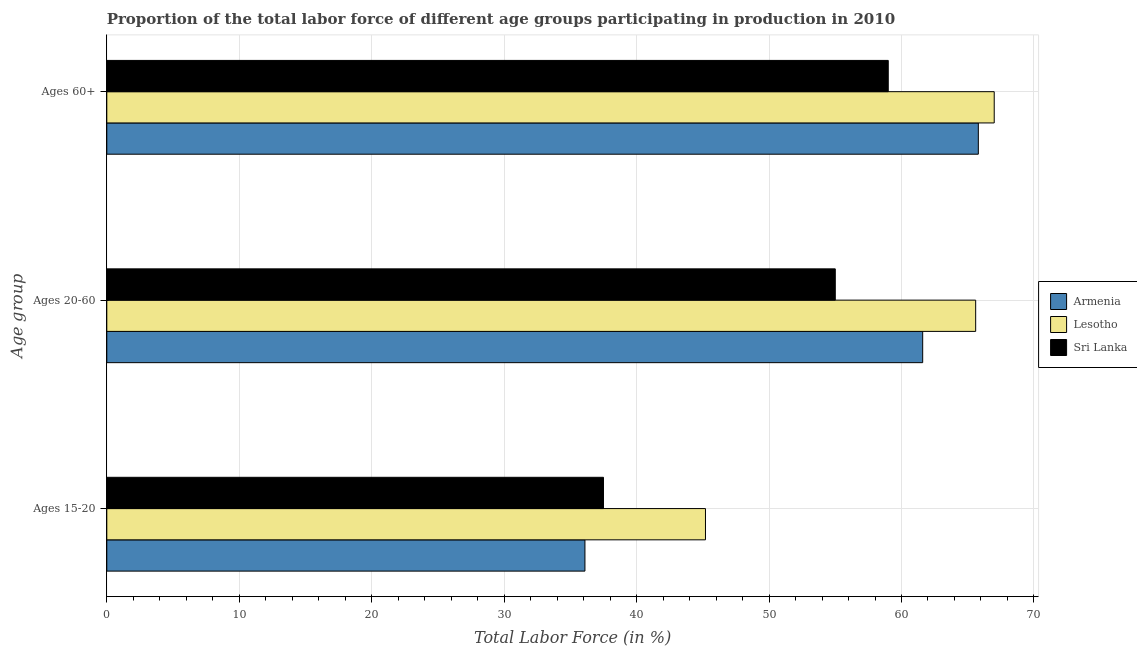How many groups of bars are there?
Keep it short and to the point. 3. How many bars are there on the 2nd tick from the bottom?
Ensure brevity in your answer.  3. What is the label of the 2nd group of bars from the top?
Offer a very short reply. Ages 20-60. What is the percentage of labor force within the age group 15-20 in Lesotho?
Provide a short and direct response. 45.2. Across all countries, what is the maximum percentage of labor force within the age group 20-60?
Make the answer very short. 65.6. Across all countries, what is the minimum percentage of labor force within the age group 15-20?
Your answer should be very brief. 36.1. In which country was the percentage of labor force within the age group 15-20 maximum?
Your answer should be very brief. Lesotho. In which country was the percentage of labor force within the age group 20-60 minimum?
Provide a succinct answer. Sri Lanka. What is the total percentage of labor force within the age group 20-60 in the graph?
Keep it short and to the point. 182.2. What is the difference between the percentage of labor force within the age group 20-60 in Lesotho and the percentage of labor force within the age group 15-20 in Sri Lanka?
Your response must be concise. 28.1. What is the average percentage of labor force within the age group 15-20 per country?
Make the answer very short. 39.6. What is the difference between the percentage of labor force within the age group 20-60 and percentage of labor force within the age group 15-20 in Armenia?
Your answer should be compact. 25.5. In how many countries, is the percentage of labor force within the age group 20-60 greater than 6 %?
Provide a short and direct response. 3. What is the ratio of the percentage of labor force within the age group 15-20 in Lesotho to that in Armenia?
Offer a very short reply. 1.25. Is the percentage of labor force within the age group 15-20 in Lesotho less than that in Armenia?
Your answer should be very brief. No. Is the difference between the percentage of labor force within the age group 15-20 in Armenia and Lesotho greater than the difference between the percentage of labor force within the age group 20-60 in Armenia and Lesotho?
Ensure brevity in your answer.  No. What is the difference between the highest and the second highest percentage of labor force above age 60?
Make the answer very short. 1.2. What is the difference between the highest and the lowest percentage of labor force above age 60?
Provide a short and direct response. 8. In how many countries, is the percentage of labor force above age 60 greater than the average percentage of labor force above age 60 taken over all countries?
Your answer should be very brief. 2. Is the sum of the percentage of labor force within the age group 20-60 in Armenia and Lesotho greater than the maximum percentage of labor force above age 60 across all countries?
Give a very brief answer. Yes. What does the 3rd bar from the top in Ages 60+ represents?
Your answer should be very brief. Armenia. What does the 3rd bar from the bottom in Ages 20-60 represents?
Offer a terse response. Sri Lanka. Is it the case that in every country, the sum of the percentage of labor force within the age group 15-20 and percentage of labor force within the age group 20-60 is greater than the percentage of labor force above age 60?
Provide a short and direct response. Yes. How many bars are there?
Make the answer very short. 9. What is the difference between two consecutive major ticks on the X-axis?
Keep it short and to the point. 10. Are the values on the major ticks of X-axis written in scientific E-notation?
Give a very brief answer. No. How many legend labels are there?
Your answer should be compact. 3. What is the title of the graph?
Make the answer very short. Proportion of the total labor force of different age groups participating in production in 2010. Does "South Asia" appear as one of the legend labels in the graph?
Your answer should be very brief. No. What is the label or title of the Y-axis?
Provide a succinct answer. Age group. What is the Total Labor Force (in %) in Armenia in Ages 15-20?
Your response must be concise. 36.1. What is the Total Labor Force (in %) in Lesotho in Ages 15-20?
Your response must be concise. 45.2. What is the Total Labor Force (in %) of Sri Lanka in Ages 15-20?
Your response must be concise. 37.5. What is the Total Labor Force (in %) in Armenia in Ages 20-60?
Make the answer very short. 61.6. What is the Total Labor Force (in %) in Lesotho in Ages 20-60?
Provide a short and direct response. 65.6. What is the Total Labor Force (in %) in Sri Lanka in Ages 20-60?
Give a very brief answer. 55. What is the Total Labor Force (in %) of Armenia in Ages 60+?
Offer a very short reply. 65.8. What is the Total Labor Force (in %) in Sri Lanka in Ages 60+?
Your answer should be compact. 59. Across all Age group, what is the maximum Total Labor Force (in %) in Armenia?
Make the answer very short. 65.8. Across all Age group, what is the maximum Total Labor Force (in %) in Lesotho?
Keep it short and to the point. 67. Across all Age group, what is the minimum Total Labor Force (in %) of Armenia?
Offer a very short reply. 36.1. Across all Age group, what is the minimum Total Labor Force (in %) of Lesotho?
Keep it short and to the point. 45.2. Across all Age group, what is the minimum Total Labor Force (in %) of Sri Lanka?
Your answer should be very brief. 37.5. What is the total Total Labor Force (in %) in Armenia in the graph?
Provide a short and direct response. 163.5. What is the total Total Labor Force (in %) in Lesotho in the graph?
Provide a short and direct response. 177.8. What is the total Total Labor Force (in %) in Sri Lanka in the graph?
Offer a terse response. 151.5. What is the difference between the Total Labor Force (in %) of Armenia in Ages 15-20 and that in Ages 20-60?
Your answer should be very brief. -25.5. What is the difference between the Total Labor Force (in %) in Lesotho in Ages 15-20 and that in Ages 20-60?
Offer a very short reply. -20.4. What is the difference between the Total Labor Force (in %) of Sri Lanka in Ages 15-20 and that in Ages 20-60?
Provide a short and direct response. -17.5. What is the difference between the Total Labor Force (in %) in Armenia in Ages 15-20 and that in Ages 60+?
Your answer should be compact. -29.7. What is the difference between the Total Labor Force (in %) in Lesotho in Ages 15-20 and that in Ages 60+?
Your answer should be very brief. -21.8. What is the difference between the Total Labor Force (in %) in Sri Lanka in Ages 15-20 and that in Ages 60+?
Offer a very short reply. -21.5. What is the difference between the Total Labor Force (in %) of Sri Lanka in Ages 20-60 and that in Ages 60+?
Your answer should be compact. -4. What is the difference between the Total Labor Force (in %) of Armenia in Ages 15-20 and the Total Labor Force (in %) of Lesotho in Ages 20-60?
Ensure brevity in your answer.  -29.5. What is the difference between the Total Labor Force (in %) in Armenia in Ages 15-20 and the Total Labor Force (in %) in Sri Lanka in Ages 20-60?
Give a very brief answer. -18.9. What is the difference between the Total Labor Force (in %) of Armenia in Ages 15-20 and the Total Labor Force (in %) of Lesotho in Ages 60+?
Offer a terse response. -30.9. What is the difference between the Total Labor Force (in %) of Armenia in Ages 15-20 and the Total Labor Force (in %) of Sri Lanka in Ages 60+?
Provide a short and direct response. -22.9. What is the difference between the Total Labor Force (in %) of Lesotho in Ages 15-20 and the Total Labor Force (in %) of Sri Lanka in Ages 60+?
Ensure brevity in your answer.  -13.8. What is the difference between the Total Labor Force (in %) in Armenia in Ages 20-60 and the Total Labor Force (in %) in Lesotho in Ages 60+?
Keep it short and to the point. -5.4. What is the difference between the Total Labor Force (in %) of Armenia in Ages 20-60 and the Total Labor Force (in %) of Sri Lanka in Ages 60+?
Give a very brief answer. 2.6. What is the difference between the Total Labor Force (in %) in Lesotho in Ages 20-60 and the Total Labor Force (in %) in Sri Lanka in Ages 60+?
Make the answer very short. 6.6. What is the average Total Labor Force (in %) in Armenia per Age group?
Offer a very short reply. 54.5. What is the average Total Labor Force (in %) in Lesotho per Age group?
Your answer should be very brief. 59.27. What is the average Total Labor Force (in %) of Sri Lanka per Age group?
Give a very brief answer. 50.5. What is the difference between the Total Labor Force (in %) of Armenia and Total Labor Force (in %) of Lesotho in Ages 15-20?
Provide a short and direct response. -9.1. What is the difference between the Total Labor Force (in %) of Armenia and Total Labor Force (in %) of Sri Lanka in Ages 15-20?
Make the answer very short. -1.4. What is the difference between the Total Labor Force (in %) of Lesotho and Total Labor Force (in %) of Sri Lanka in Ages 15-20?
Give a very brief answer. 7.7. What is the difference between the Total Labor Force (in %) of Armenia and Total Labor Force (in %) of Sri Lanka in Ages 20-60?
Your answer should be very brief. 6.6. What is the difference between the Total Labor Force (in %) of Lesotho and Total Labor Force (in %) of Sri Lanka in Ages 20-60?
Give a very brief answer. 10.6. What is the difference between the Total Labor Force (in %) of Armenia and Total Labor Force (in %) of Lesotho in Ages 60+?
Make the answer very short. -1.2. What is the ratio of the Total Labor Force (in %) in Armenia in Ages 15-20 to that in Ages 20-60?
Your answer should be very brief. 0.59. What is the ratio of the Total Labor Force (in %) in Lesotho in Ages 15-20 to that in Ages 20-60?
Provide a succinct answer. 0.69. What is the ratio of the Total Labor Force (in %) in Sri Lanka in Ages 15-20 to that in Ages 20-60?
Keep it short and to the point. 0.68. What is the ratio of the Total Labor Force (in %) of Armenia in Ages 15-20 to that in Ages 60+?
Give a very brief answer. 0.55. What is the ratio of the Total Labor Force (in %) in Lesotho in Ages 15-20 to that in Ages 60+?
Your response must be concise. 0.67. What is the ratio of the Total Labor Force (in %) in Sri Lanka in Ages 15-20 to that in Ages 60+?
Your answer should be compact. 0.64. What is the ratio of the Total Labor Force (in %) in Armenia in Ages 20-60 to that in Ages 60+?
Ensure brevity in your answer.  0.94. What is the ratio of the Total Labor Force (in %) in Lesotho in Ages 20-60 to that in Ages 60+?
Your answer should be very brief. 0.98. What is the ratio of the Total Labor Force (in %) in Sri Lanka in Ages 20-60 to that in Ages 60+?
Offer a very short reply. 0.93. What is the difference between the highest and the second highest Total Labor Force (in %) in Armenia?
Your answer should be very brief. 4.2. What is the difference between the highest and the second highest Total Labor Force (in %) of Sri Lanka?
Offer a very short reply. 4. What is the difference between the highest and the lowest Total Labor Force (in %) of Armenia?
Your answer should be compact. 29.7. What is the difference between the highest and the lowest Total Labor Force (in %) in Lesotho?
Provide a short and direct response. 21.8. 